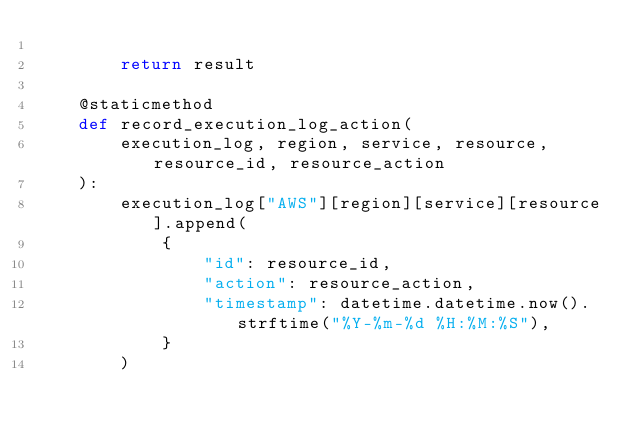<code> <loc_0><loc_0><loc_500><loc_500><_Python_>
        return result

    @staticmethod
    def record_execution_log_action(
        execution_log, region, service, resource, resource_id, resource_action
    ):
        execution_log["AWS"][region][service][resource].append(
            {
                "id": resource_id,
                "action": resource_action,
                "timestamp": datetime.datetime.now().strftime("%Y-%m-%d %H:%M:%S"),
            }
        )
</code> 